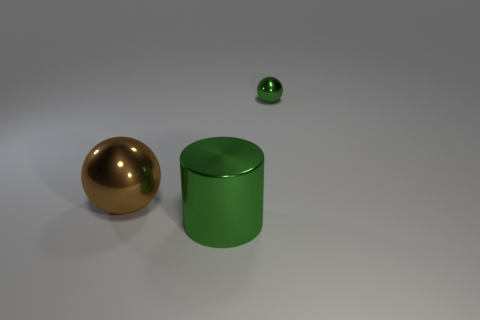Add 1 tiny yellow blocks. How many objects exist? 4 Subtract all cylinders. How many objects are left? 2 Subtract all small red metallic cylinders. Subtract all shiny spheres. How many objects are left? 1 Add 2 large cylinders. How many large cylinders are left? 3 Add 1 green metallic balls. How many green metallic balls exist? 2 Subtract 1 brown spheres. How many objects are left? 2 